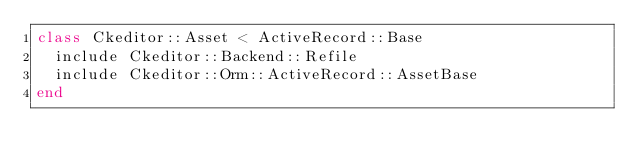Convert code to text. <code><loc_0><loc_0><loc_500><loc_500><_Ruby_>class Ckeditor::Asset < ActiveRecord::Base
  include Ckeditor::Backend::Refile
  include Ckeditor::Orm::ActiveRecord::AssetBase
end
</code> 